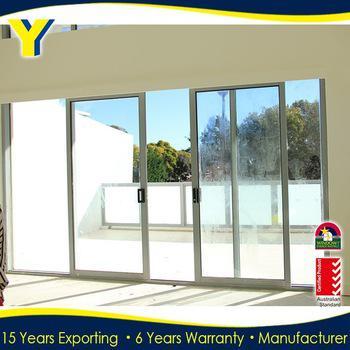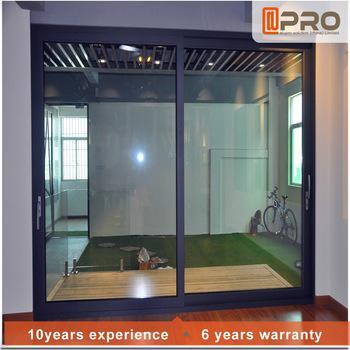The first image is the image on the left, the second image is the image on the right. For the images shown, is this caption "An image shows a square sliding glass unit with just two side-by-side glass panes." true? Answer yes or no. Yes. 